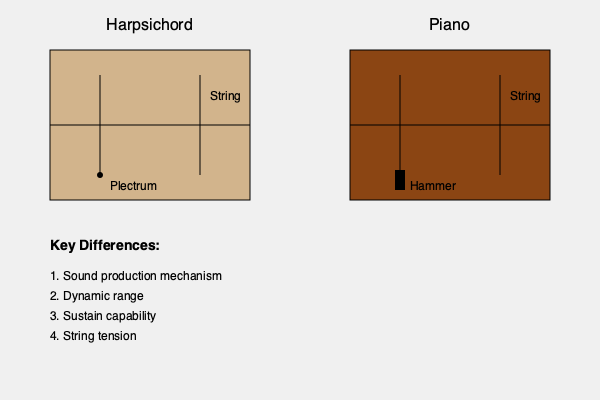Compare and contrast the mechanisms of sound production in a harpsichord and a modern piano, as shown in the cross-sectional diagrams. How do these differences affect the musical capabilities of each instrument, particularly in the context of performing Bach's compositions? 1. Sound production mechanism:
   - Harpsichord: Uses a plectrum to pluck the string
   - Piano: Uses a hammer to strike the string

2. Dynamic range:
   - Harpsichord: Limited dynamic range due to plucking mechanism
   - Piano: Wide dynamic range due to hammer mechanism allowing varied force

3. Sustain capability:
   - Harpsichord: Short sustain, as strings are plucked
   - Piano: Longer sustain, as strings are struck and can vibrate freely

4. String tension:
   - Harpsichord: Lower string tension
   - Piano: Higher string tension, allowing for greater volume

5. Effect on Bach's compositions:
   - Harpsichord:
     a) Suited for crisp articulation in contrapuntal works
     b) Limited expressive capabilities in terms of volume changes
   - Piano:
     a) Allows for more nuanced dynamics, enhancing emotional expression
     b) Sustain pedal can blend harmonies, potentially altering the clarity of Bach's counterpoint

6. Historical context:
   - Bach composed primarily for harpsichord, but his works are frequently performed on modern pianos
   - Pianists must adapt their technique to maintain the clarity and articulation intended for harpsichord while utilizing the piano's expanded capabilities

7. Musical implications:
   - Harpsichord: Emphasizes rhythmic precision and clarity of individual voices
   - Piano: Offers greater potential for tonal coloration and dynamic shaping

8. Performance considerations:
   - When performing Bach on piano, musicians often strive to balance authenticity with the expressive possibilities of the modern instrument
Answer: Harpsichord plucks strings with limited dynamics and sustain, while piano strikes strings allowing greater dynamic range and sustain. This affects the interpretation of Bach's works, requiring pianists to balance authentic articulation with modern expressive capabilities. 